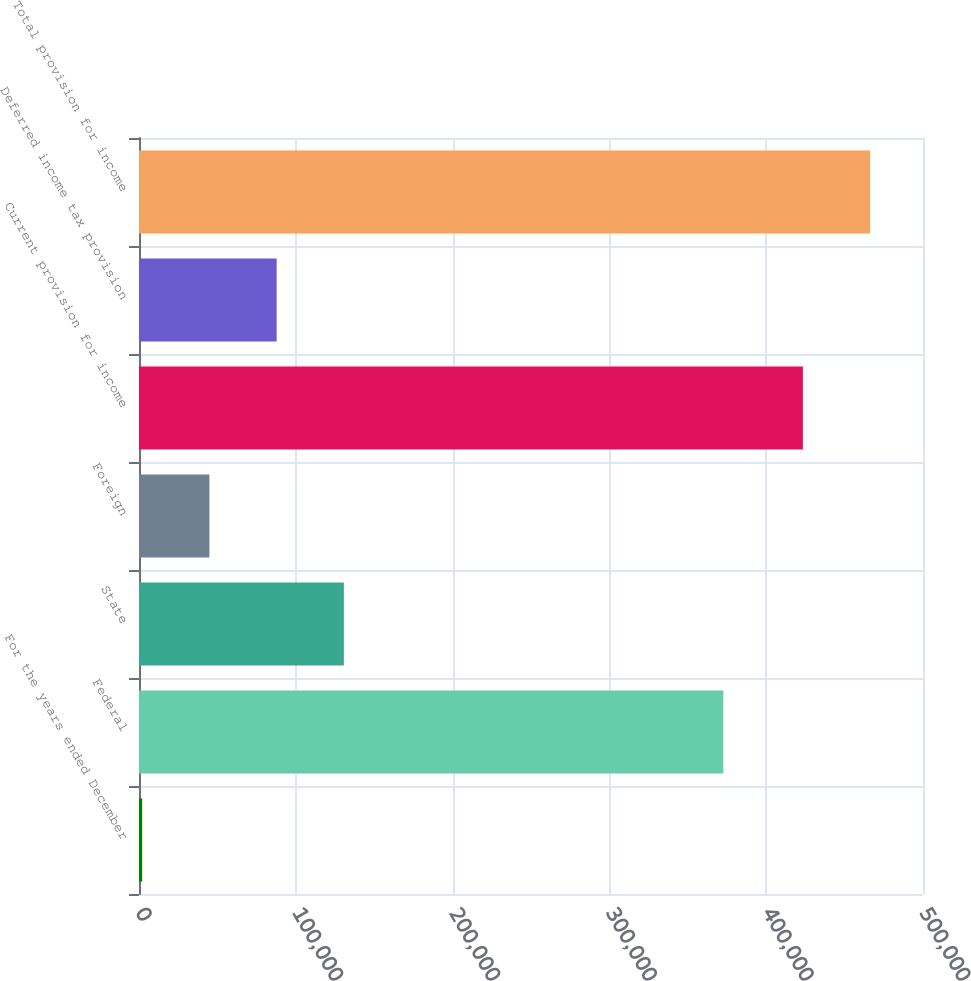Convert chart to OTSL. <chart><loc_0><loc_0><loc_500><loc_500><bar_chart><fcel>For the years ended December<fcel>Federal<fcel>State<fcel>Foreign<fcel>Current provision for income<fcel>Deferred income tax provision<fcel>Total provision for income<nl><fcel>2013<fcel>372649<fcel>130664<fcel>44896.6<fcel>423392<fcel>87780.2<fcel>466276<nl></chart> 